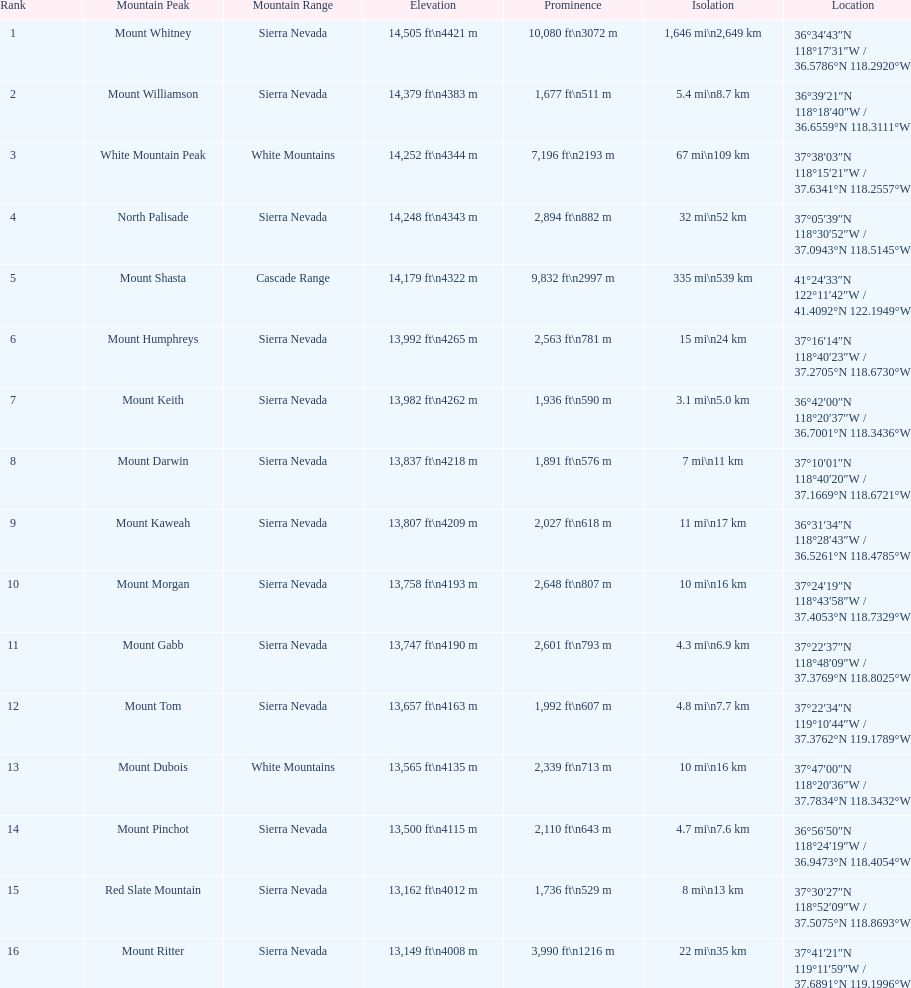What single mountain peak is specified for the cascade range? Mount Shasta. 